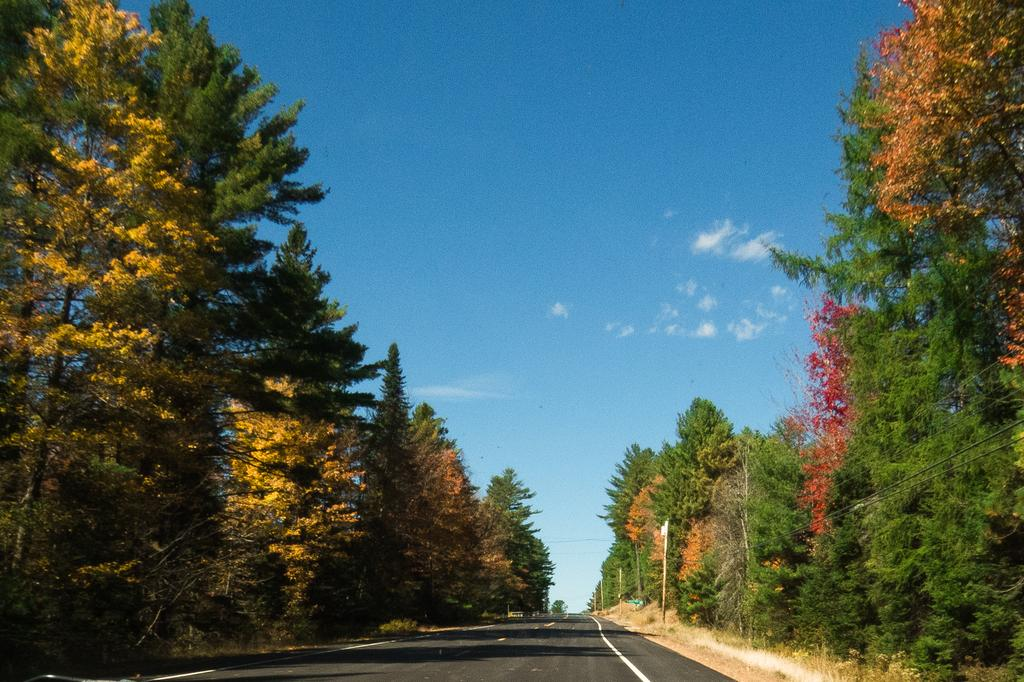What type of vegetation can be seen in the image? There are trees in the image. What is located in the center of the image? There is a road in the center of the image. What is the condition of the sky in the image? The sky is cloudy in the image. Can you tell me how many uncles are walking on the road in the image? There are no uncles present in the image; it only features trees, a road, and a cloudy sky. What type of fowl can be seen flying over the trees in the image? There are no fowl visible in the image; it only features trees, a road, and a cloudy sky. 